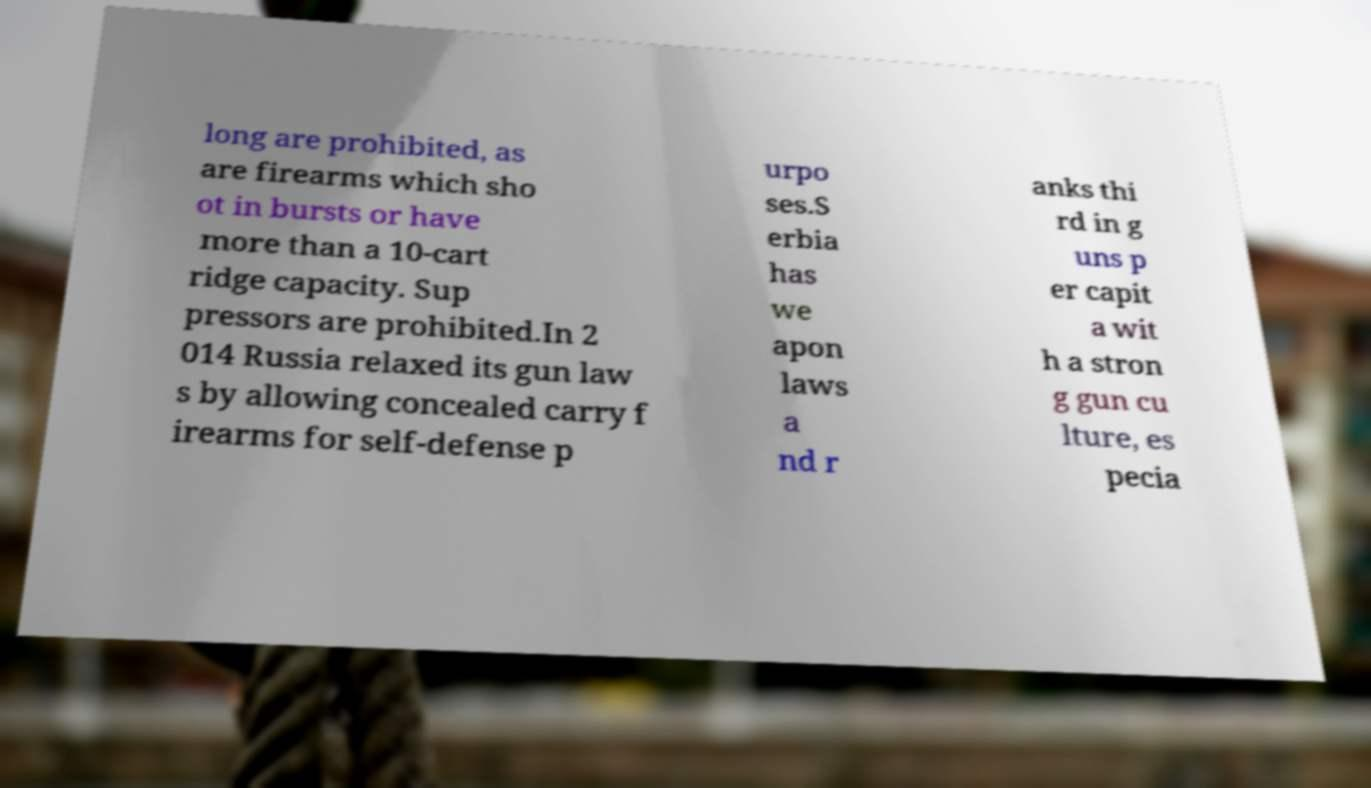There's text embedded in this image that I need extracted. Can you transcribe it verbatim? long are prohibited, as are firearms which sho ot in bursts or have more than a 10-cart ridge capacity. Sup pressors are prohibited.In 2 014 Russia relaxed its gun law s by allowing concealed carry f irearms for self-defense p urpo ses.S erbia has we apon laws a nd r anks thi rd in g uns p er capit a wit h a stron g gun cu lture, es pecia 